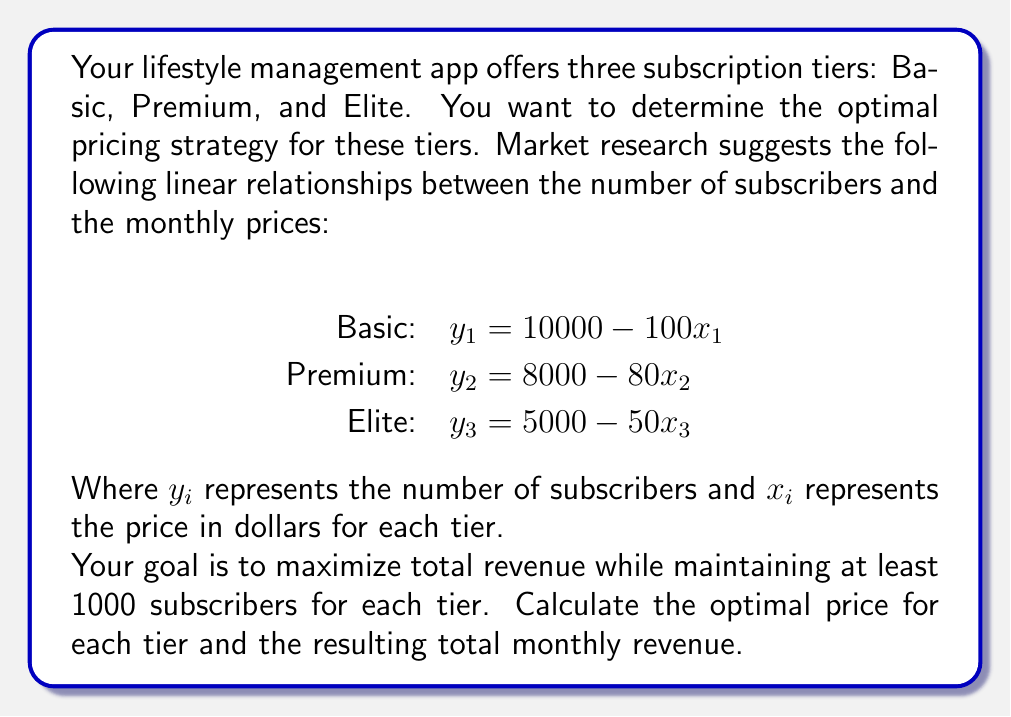Could you help me with this problem? To solve this problem, we'll follow these steps:

1) The revenue for each tier is given by the product of the number of subscribers and the price. We can express this as:

   Basic: $R_1 = x_1y_1 = x_1(10000 - 100x_1)$
   Premium: $R_2 = x_2y_2 = x_2(8000 - 80x_2)$
   Elite: $R_3 = x_3y_3 = x_3(5000 - 50x_3)$

2) To maximize revenue for each tier, we need to find the vertex of each parabola. We can do this by setting the derivative of each revenue function to zero:

   For Basic: $\frac{dR_1}{dx_1} = 10000 - 200x_1 = 0$
              $200x_1 = 10000$
              $x_1 = 50$

   For Premium: $\frac{dR_2}{dx_2} = 8000 - 160x_2 = 0$
                $160x_2 = 8000$
                $x_2 = 50$

   For Elite: $\frac{dR_3}{dx_3} = 5000 - 100x_3 = 0$
              $100x_3 = 5000$
              $x_3 = 50$

3) Now, we need to check if these prices satisfy the constraint of at least 1000 subscribers for each tier:

   Basic: $y_1 = 10000 - 100(50) = 5000$ subscribers
   Premium: $y_2 = 8000 - 80(50) = 4000$ subscribers
   Elite: $y_3 = 5000 - 50(50) = 2500$ subscribers

   All tiers satisfy the constraint.

4) Calculate the revenue for each tier:

   Basic: $R_1 = 50 * 5000 = 250,000$
   Premium: $R_2 = 50 * 4000 = 200,000$
   Elite: $R_3 = 50 * 2500 = 125,000$

5) Calculate the total monthly revenue:

   Total Revenue = $250,000 + 200,000 + 125,000 = 575,000$

Therefore, the optimal pricing strategy is to price all tiers at $50, which results in a total monthly revenue of $575,000.
Answer: Optimal price for all tiers: $50. Total monthly revenue: $575,000. 